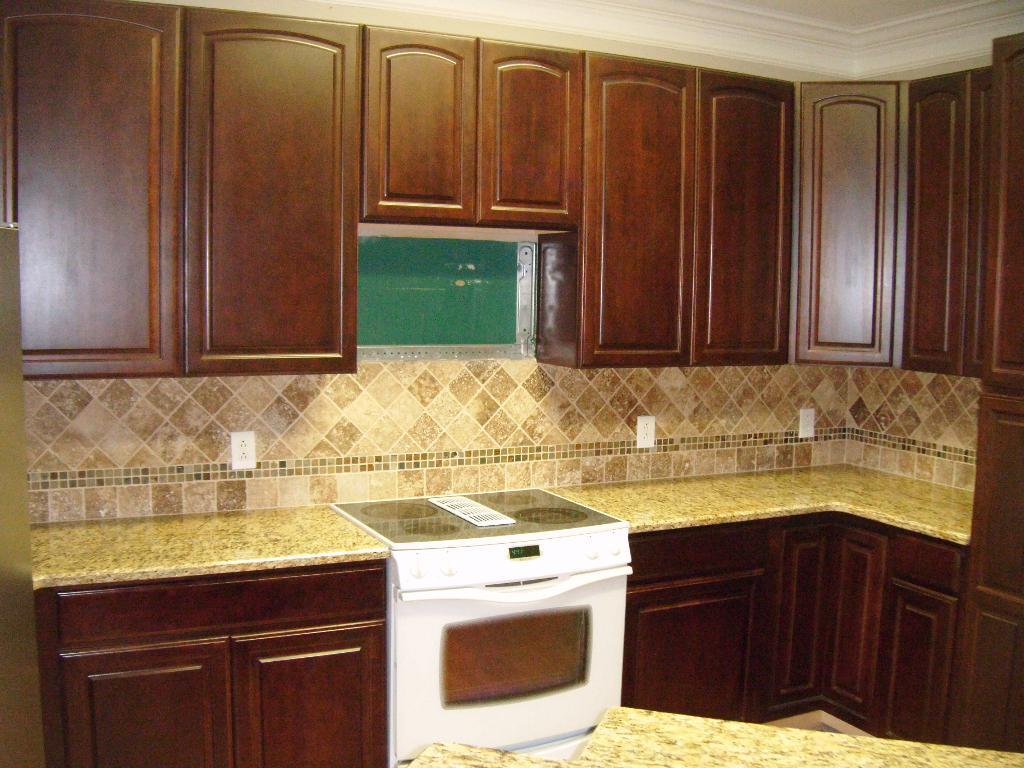What type of space is shown in the image? The image is an inside view of a room. What furniture or fixtures are present at the bottom of the room? There are table cabinets at the bottom of the room. What type of equipment is present in the room? There is a machine tool in the room. What type of storage units are present at the top of the room? There are cupboards at the top of the room. How does the committee contribute to the pollution in the room? There is no committee present in the image, and therefore no pollution can be attributed to it. 